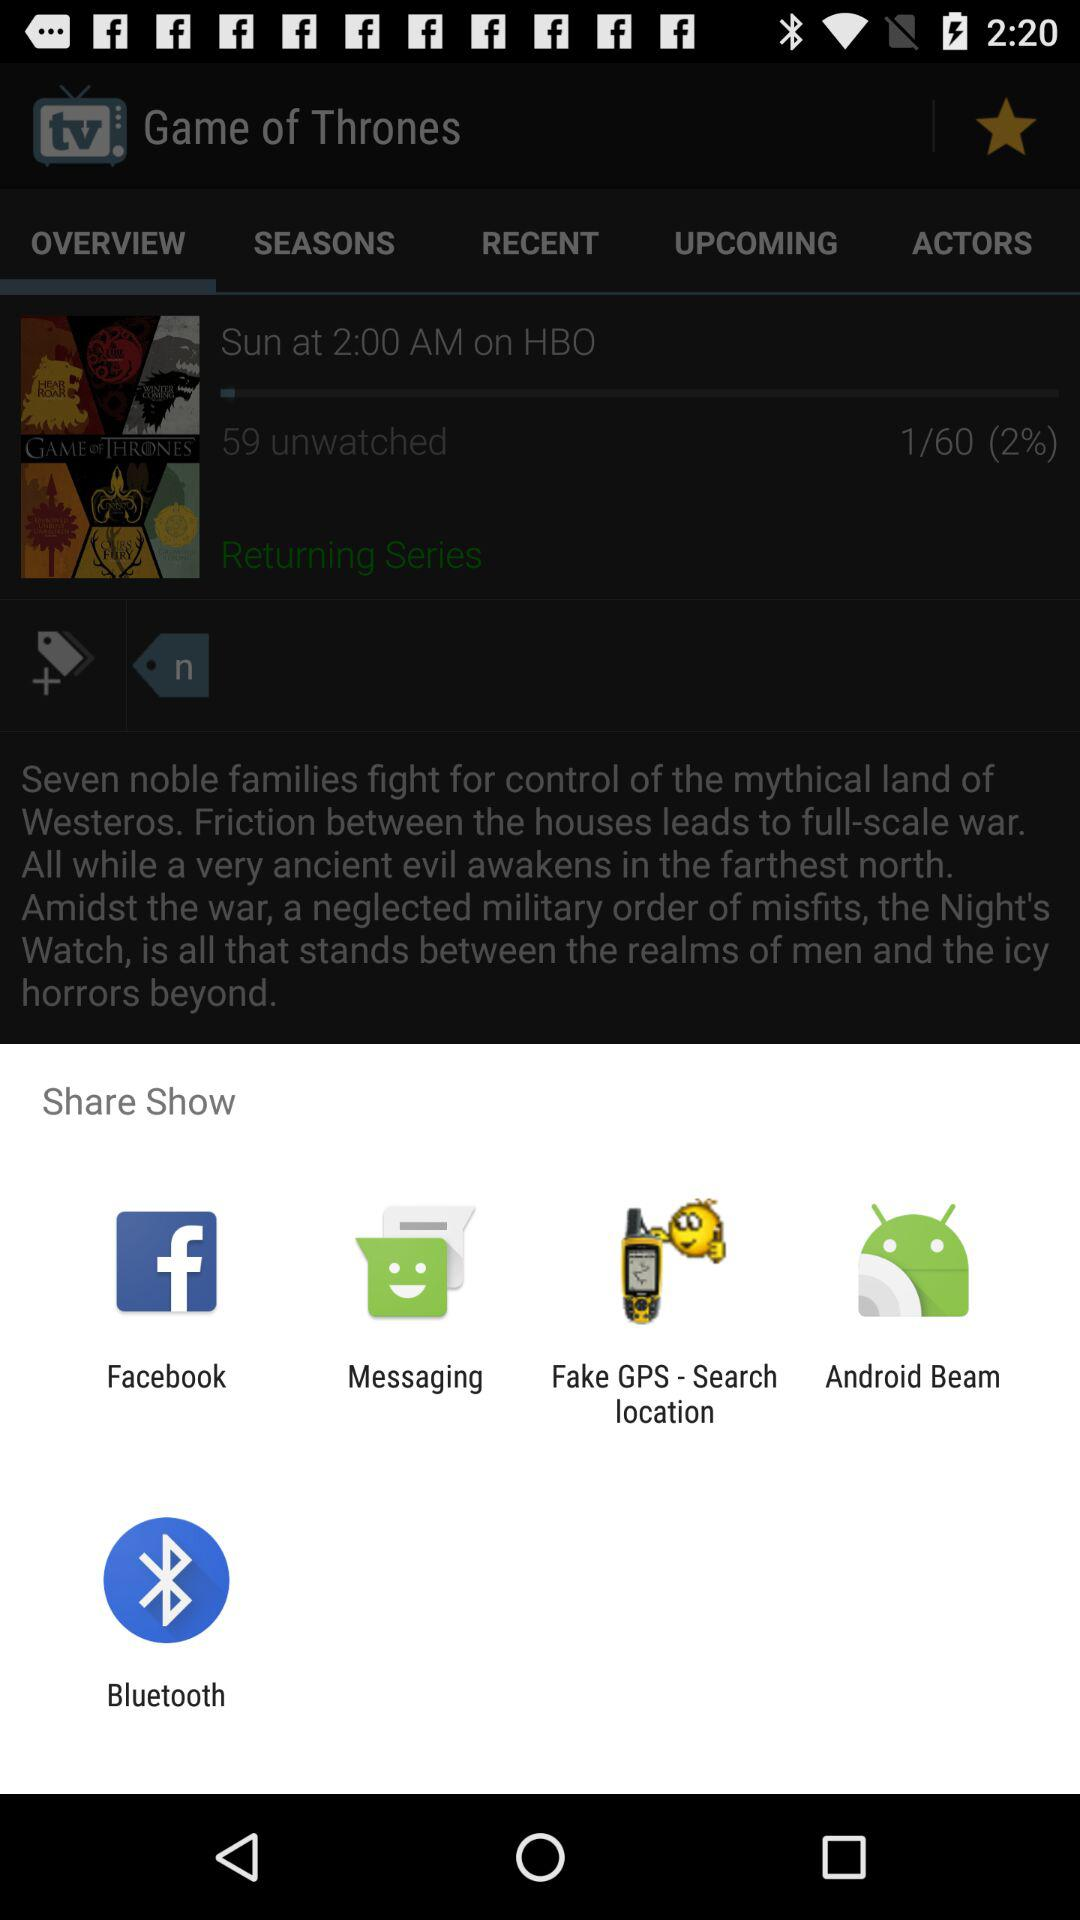How many unwatched episodes of Game of Thrones are there?
Answer the question using a single word or phrase. 59 